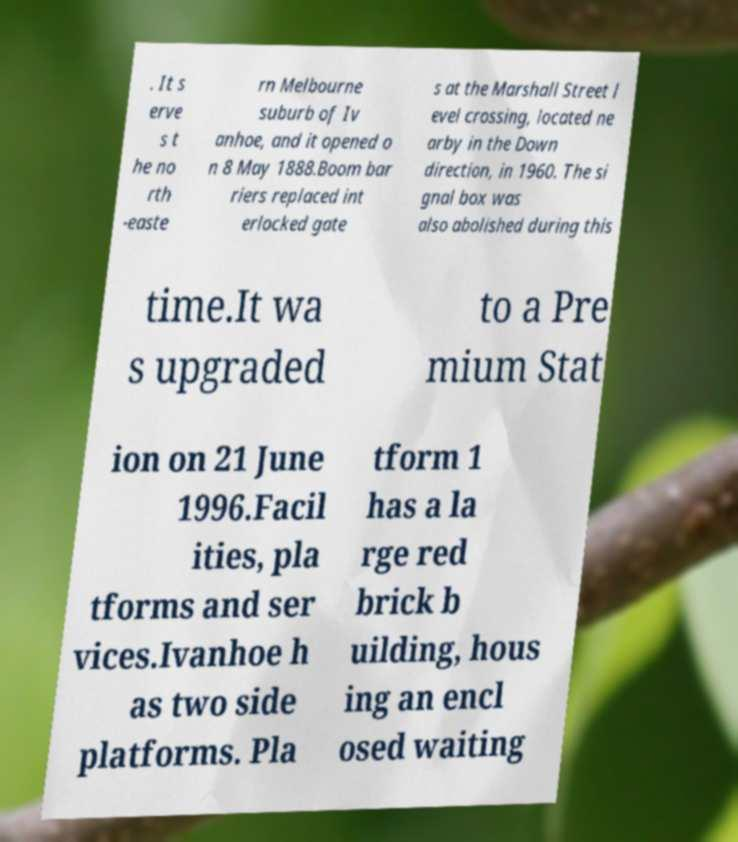Can you read and provide the text displayed in the image?This photo seems to have some interesting text. Can you extract and type it out for me? . It s erve s t he no rth -easte rn Melbourne suburb of Iv anhoe, and it opened o n 8 May 1888.Boom bar riers replaced int erlocked gate s at the Marshall Street l evel crossing, located ne arby in the Down direction, in 1960. The si gnal box was also abolished during this time.It wa s upgraded to a Pre mium Stat ion on 21 June 1996.Facil ities, pla tforms and ser vices.Ivanhoe h as two side platforms. Pla tform 1 has a la rge red brick b uilding, hous ing an encl osed waiting 